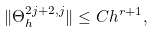<formula> <loc_0><loc_0><loc_500><loc_500>\| \Theta ^ { 2 j + 2 , j } _ { h } \| \leq C h ^ { r + 1 } ,</formula> 